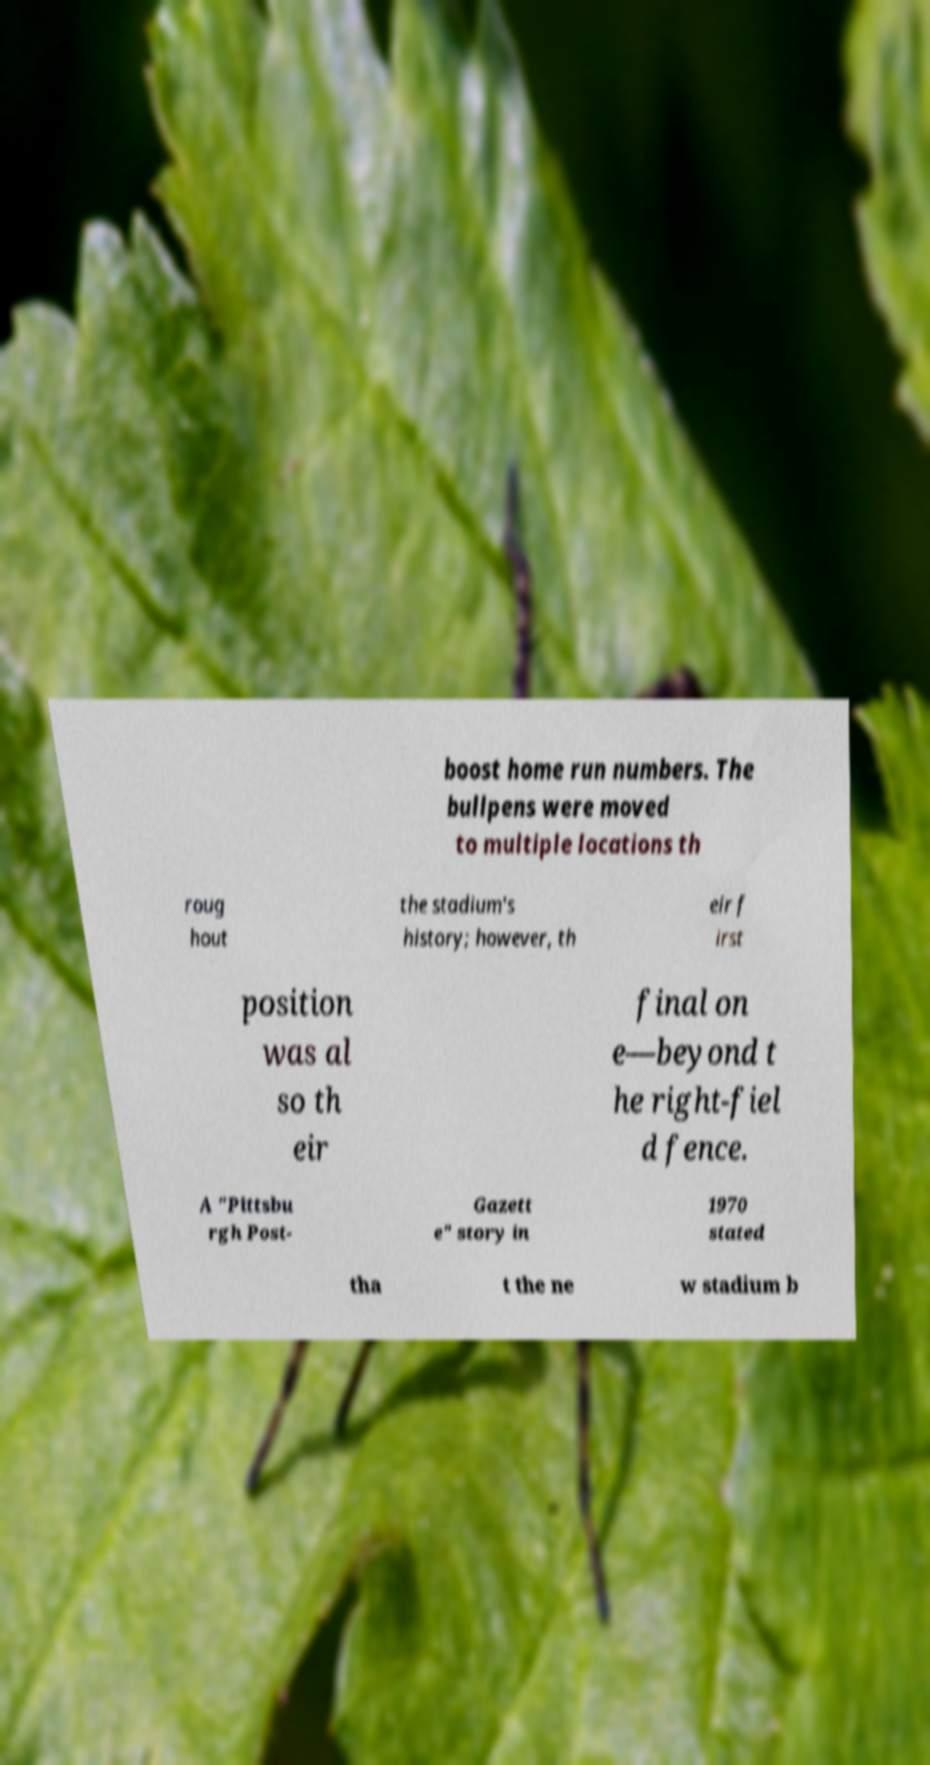There's text embedded in this image that I need extracted. Can you transcribe it verbatim? boost home run numbers. The bullpens were moved to multiple locations th roug hout the stadium's history; however, th eir f irst position was al so th eir final on e—beyond t he right-fiel d fence. A "Pittsbu rgh Post- Gazett e" story in 1970 stated tha t the ne w stadium b 